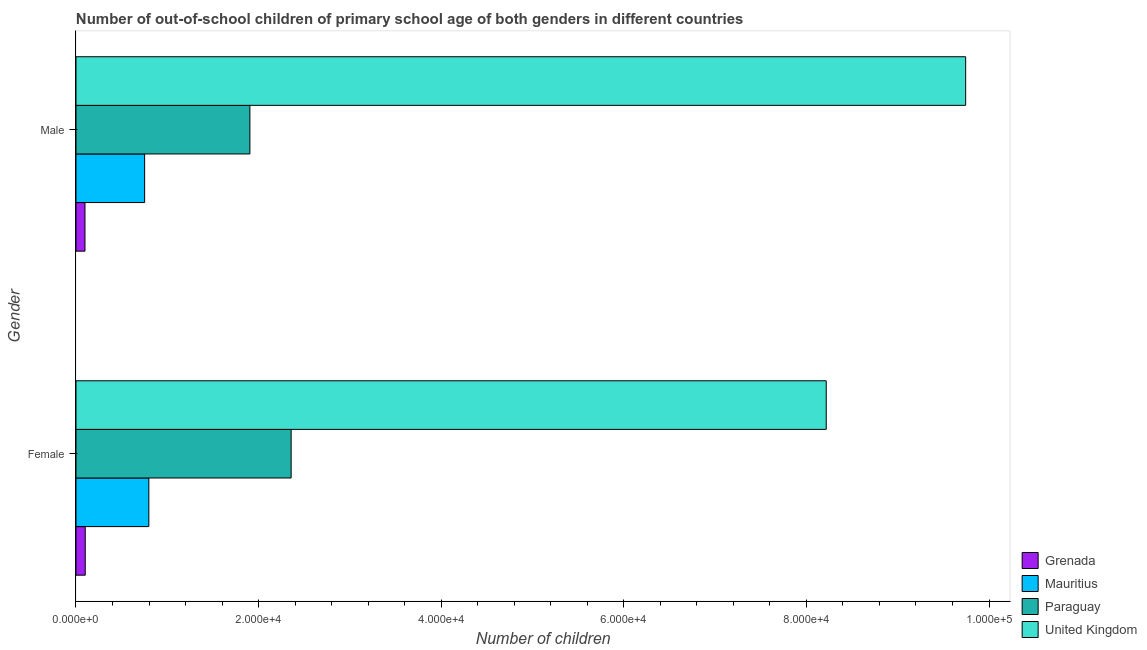Are the number of bars per tick equal to the number of legend labels?
Provide a succinct answer. Yes. Are the number of bars on each tick of the Y-axis equal?
Make the answer very short. Yes. What is the number of female out-of-school students in Paraguay?
Offer a very short reply. 2.36e+04. Across all countries, what is the maximum number of male out-of-school students?
Provide a short and direct response. 9.74e+04. Across all countries, what is the minimum number of female out-of-school students?
Ensure brevity in your answer.  1013. In which country was the number of female out-of-school students minimum?
Offer a very short reply. Grenada. What is the total number of male out-of-school students in the graph?
Offer a very short reply. 1.25e+05. What is the difference between the number of female out-of-school students in Grenada and that in United Kingdom?
Offer a terse response. -8.12e+04. What is the difference between the number of male out-of-school students in Paraguay and the number of female out-of-school students in Mauritius?
Keep it short and to the point. 1.11e+04. What is the average number of male out-of-school students per country?
Your response must be concise. 3.12e+04. What is the difference between the number of female out-of-school students and number of male out-of-school students in Paraguay?
Your answer should be compact. 4519. What is the ratio of the number of female out-of-school students in United Kingdom to that in Grenada?
Offer a terse response. 81.11. Is the number of female out-of-school students in Grenada less than that in Mauritius?
Provide a succinct answer. Yes. In how many countries, is the number of male out-of-school students greater than the average number of male out-of-school students taken over all countries?
Offer a very short reply. 1. What does the 2nd bar from the top in Female represents?
Your response must be concise. Paraguay. What does the 2nd bar from the bottom in Male represents?
Offer a very short reply. Mauritius. How many bars are there?
Ensure brevity in your answer.  8. Are all the bars in the graph horizontal?
Your answer should be very brief. Yes. How many countries are there in the graph?
Offer a very short reply. 4. What is the difference between two consecutive major ticks on the X-axis?
Keep it short and to the point. 2.00e+04. Does the graph contain any zero values?
Offer a terse response. No. How many legend labels are there?
Your response must be concise. 4. What is the title of the graph?
Provide a succinct answer. Number of out-of-school children of primary school age of both genders in different countries. Does "Mauritania" appear as one of the legend labels in the graph?
Ensure brevity in your answer.  No. What is the label or title of the X-axis?
Offer a terse response. Number of children. What is the Number of children of Grenada in Female?
Give a very brief answer. 1013. What is the Number of children of Mauritius in Female?
Provide a succinct answer. 7979. What is the Number of children in Paraguay in Female?
Provide a short and direct response. 2.36e+04. What is the Number of children in United Kingdom in Female?
Make the answer very short. 8.22e+04. What is the Number of children in Grenada in Male?
Offer a very short reply. 986. What is the Number of children of Mauritius in Male?
Keep it short and to the point. 7518. What is the Number of children in Paraguay in Male?
Your answer should be very brief. 1.90e+04. What is the Number of children of United Kingdom in Male?
Your answer should be very brief. 9.74e+04. Across all Gender, what is the maximum Number of children of Grenada?
Your response must be concise. 1013. Across all Gender, what is the maximum Number of children in Mauritius?
Ensure brevity in your answer.  7979. Across all Gender, what is the maximum Number of children in Paraguay?
Give a very brief answer. 2.36e+04. Across all Gender, what is the maximum Number of children of United Kingdom?
Offer a terse response. 9.74e+04. Across all Gender, what is the minimum Number of children of Grenada?
Ensure brevity in your answer.  986. Across all Gender, what is the minimum Number of children in Mauritius?
Your answer should be compact. 7518. Across all Gender, what is the minimum Number of children of Paraguay?
Give a very brief answer. 1.90e+04. Across all Gender, what is the minimum Number of children of United Kingdom?
Provide a succinct answer. 8.22e+04. What is the total Number of children in Grenada in the graph?
Ensure brevity in your answer.  1999. What is the total Number of children in Mauritius in the graph?
Provide a succinct answer. 1.55e+04. What is the total Number of children of Paraguay in the graph?
Your answer should be very brief. 4.26e+04. What is the total Number of children in United Kingdom in the graph?
Make the answer very short. 1.80e+05. What is the difference between the Number of children of Mauritius in Female and that in Male?
Make the answer very short. 461. What is the difference between the Number of children of Paraguay in Female and that in Male?
Your answer should be compact. 4519. What is the difference between the Number of children in United Kingdom in Female and that in Male?
Offer a very short reply. -1.53e+04. What is the difference between the Number of children of Grenada in Female and the Number of children of Mauritius in Male?
Offer a terse response. -6505. What is the difference between the Number of children of Grenada in Female and the Number of children of Paraguay in Male?
Your answer should be very brief. -1.80e+04. What is the difference between the Number of children in Grenada in Female and the Number of children in United Kingdom in Male?
Make the answer very short. -9.64e+04. What is the difference between the Number of children in Mauritius in Female and the Number of children in Paraguay in Male?
Ensure brevity in your answer.  -1.11e+04. What is the difference between the Number of children in Mauritius in Female and the Number of children in United Kingdom in Male?
Your response must be concise. -8.95e+04. What is the difference between the Number of children of Paraguay in Female and the Number of children of United Kingdom in Male?
Make the answer very short. -7.39e+04. What is the average Number of children of Grenada per Gender?
Make the answer very short. 999.5. What is the average Number of children of Mauritius per Gender?
Offer a terse response. 7748.5. What is the average Number of children in Paraguay per Gender?
Give a very brief answer. 2.13e+04. What is the average Number of children in United Kingdom per Gender?
Offer a terse response. 8.98e+04. What is the difference between the Number of children in Grenada and Number of children in Mauritius in Female?
Your response must be concise. -6966. What is the difference between the Number of children of Grenada and Number of children of Paraguay in Female?
Your response must be concise. -2.26e+04. What is the difference between the Number of children in Grenada and Number of children in United Kingdom in Female?
Keep it short and to the point. -8.12e+04. What is the difference between the Number of children in Mauritius and Number of children in Paraguay in Female?
Provide a succinct answer. -1.56e+04. What is the difference between the Number of children in Mauritius and Number of children in United Kingdom in Female?
Keep it short and to the point. -7.42e+04. What is the difference between the Number of children in Paraguay and Number of children in United Kingdom in Female?
Offer a very short reply. -5.86e+04. What is the difference between the Number of children in Grenada and Number of children in Mauritius in Male?
Provide a succinct answer. -6532. What is the difference between the Number of children in Grenada and Number of children in Paraguay in Male?
Provide a short and direct response. -1.81e+04. What is the difference between the Number of children in Grenada and Number of children in United Kingdom in Male?
Make the answer very short. -9.65e+04. What is the difference between the Number of children in Mauritius and Number of children in Paraguay in Male?
Your answer should be compact. -1.15e+04. What is the difference between the Number of children in Mauritius and Number of children in United Kingdom in Male?
Provide a succinct answer. -8.99e+04. What is the difference between the Number of children of Paraguay and Number of children of United Kingdom in Male?
Offer a very short reply. -7.84e+04. What is the ratio of the Number of children in Grenada in Female to that in Male?
Offer a terse response. 1.03. What is the ratio of the Number of children of Mauritius in Female to that in Male?
Ensure brevity in your answer.  1.06. What is the ratio of the Number of children in Paraguay in Female to that in Male?
Keep it short and to the point. 1.24. What is the ratio of the Number of children in United Kingdom in Female to that in Male?
Your answer should be compact. 0.84. What is the difference between the highest and the second highest Number of children of Grenada?
Your response must be concise. 27. What is the difference between the highest and the second highest Number of children in Mauritius?
Ensure brevity in your answer.  461. What is the difference between the highest and the second highest Number of children in Paraguay?
Give a very brief answer. 4519. What is the difference between the highest and the second highest Number of children of United Kingdom?
Provide a short and direct response. 1.53e+04. What is the difference between the highest and the lowest Number of children of Mauritius?
Offer a terse response. 461. What is the difference between the highest and the lowest Number of children of Paraguay?
Provide a succinct answer. 4519. What is the difference between the highest and the lowest Number of children of United Kingdom?
Provide a succinct answer. 1.53e+04. 